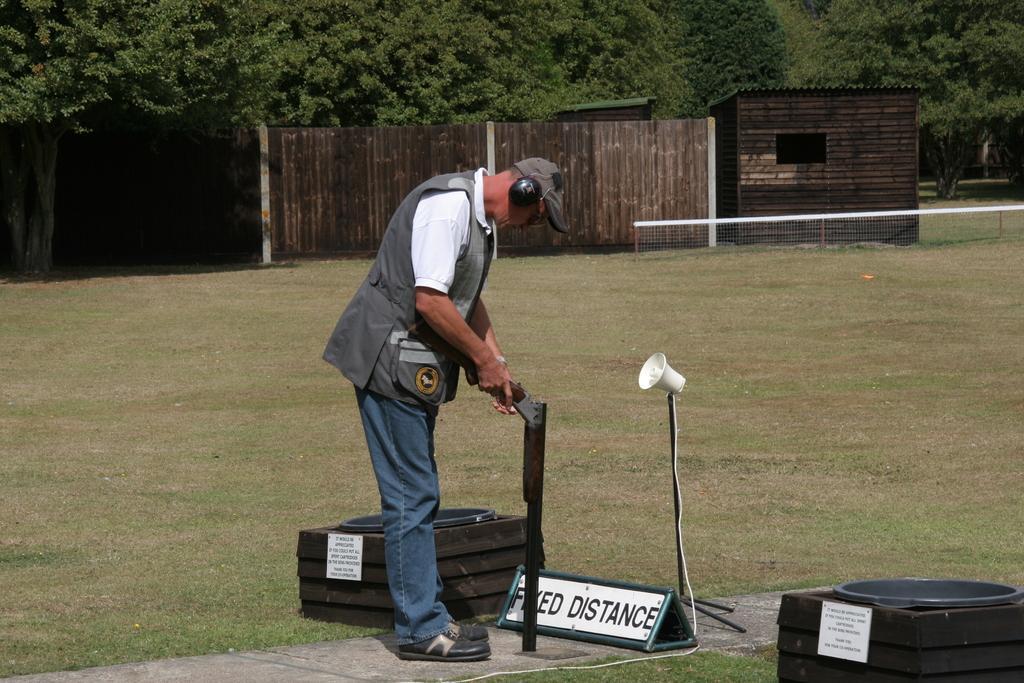Describe this image in one or two sentences. In the foreground I can see a person is standing on grass and is holding a gun in hand, metal rods and a board. In the background I can see a fence, house and trees. This image is taken may be during a day on the ground. 